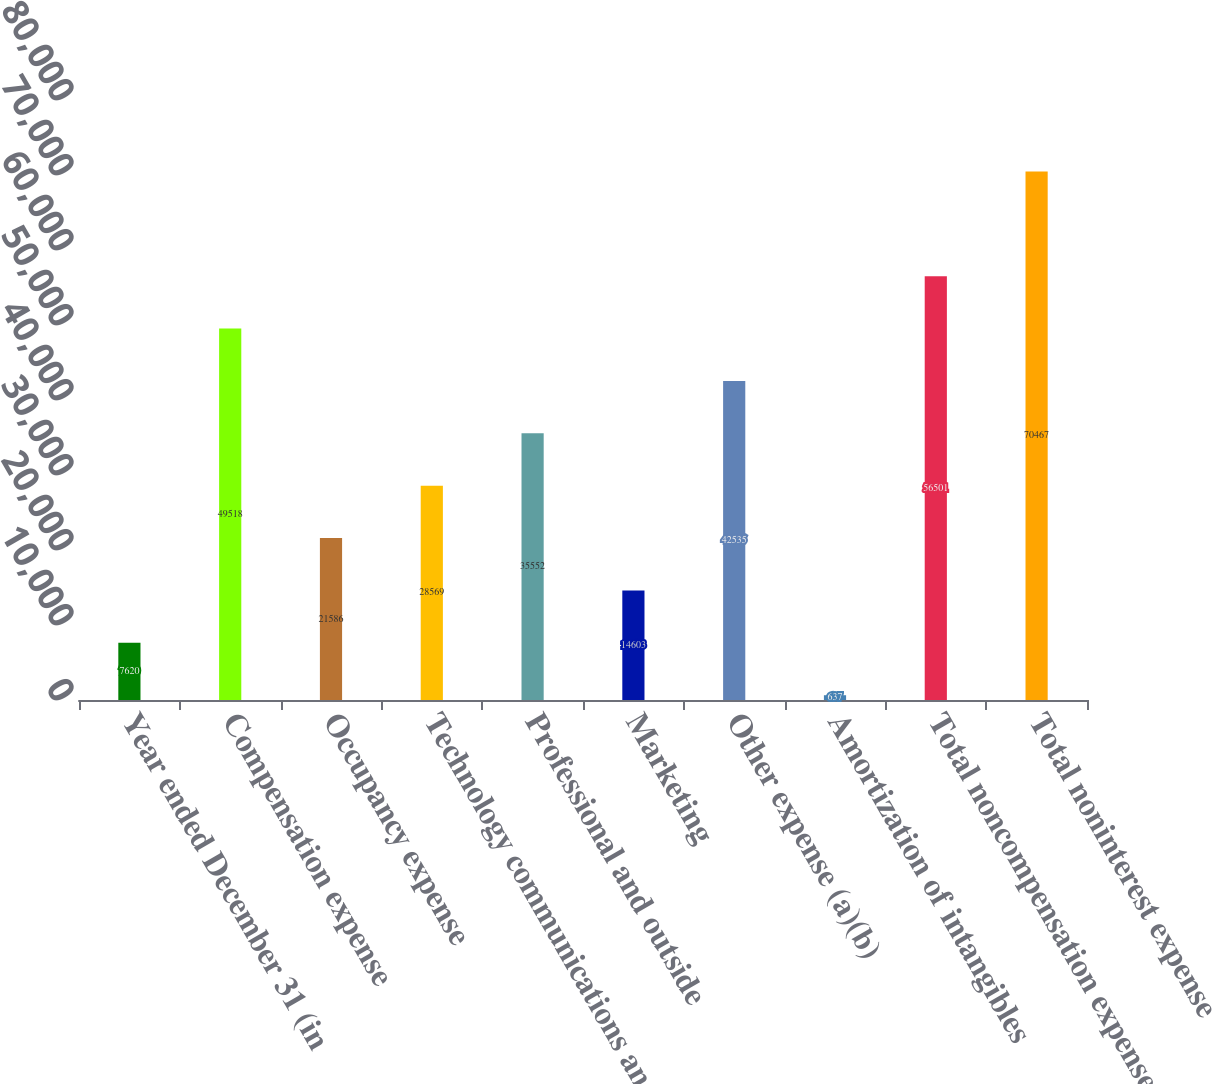Convert chart. <chart><loc_0><loc_0><loc_500><loc_500><bar_chart><fcel>Year ended December 31 (in<fcel>Compensation expense<fcel>Occupancy expense<fcel>Technology communications and<fcel>Professional and outside<fcel>Marketing<fcel>Other expense (a)(b)<fcel>Amortization of intangibles<fcel>Total noncompensation expense<fcel>Total noninterest expense<nl><fcel>7620<fcel>49518<fcel>21586<fcel>28569<fcel>35552<fcel>14603<fcel>42535<fcel>637<fcel>56501<fcel>70467<nl></chart> 